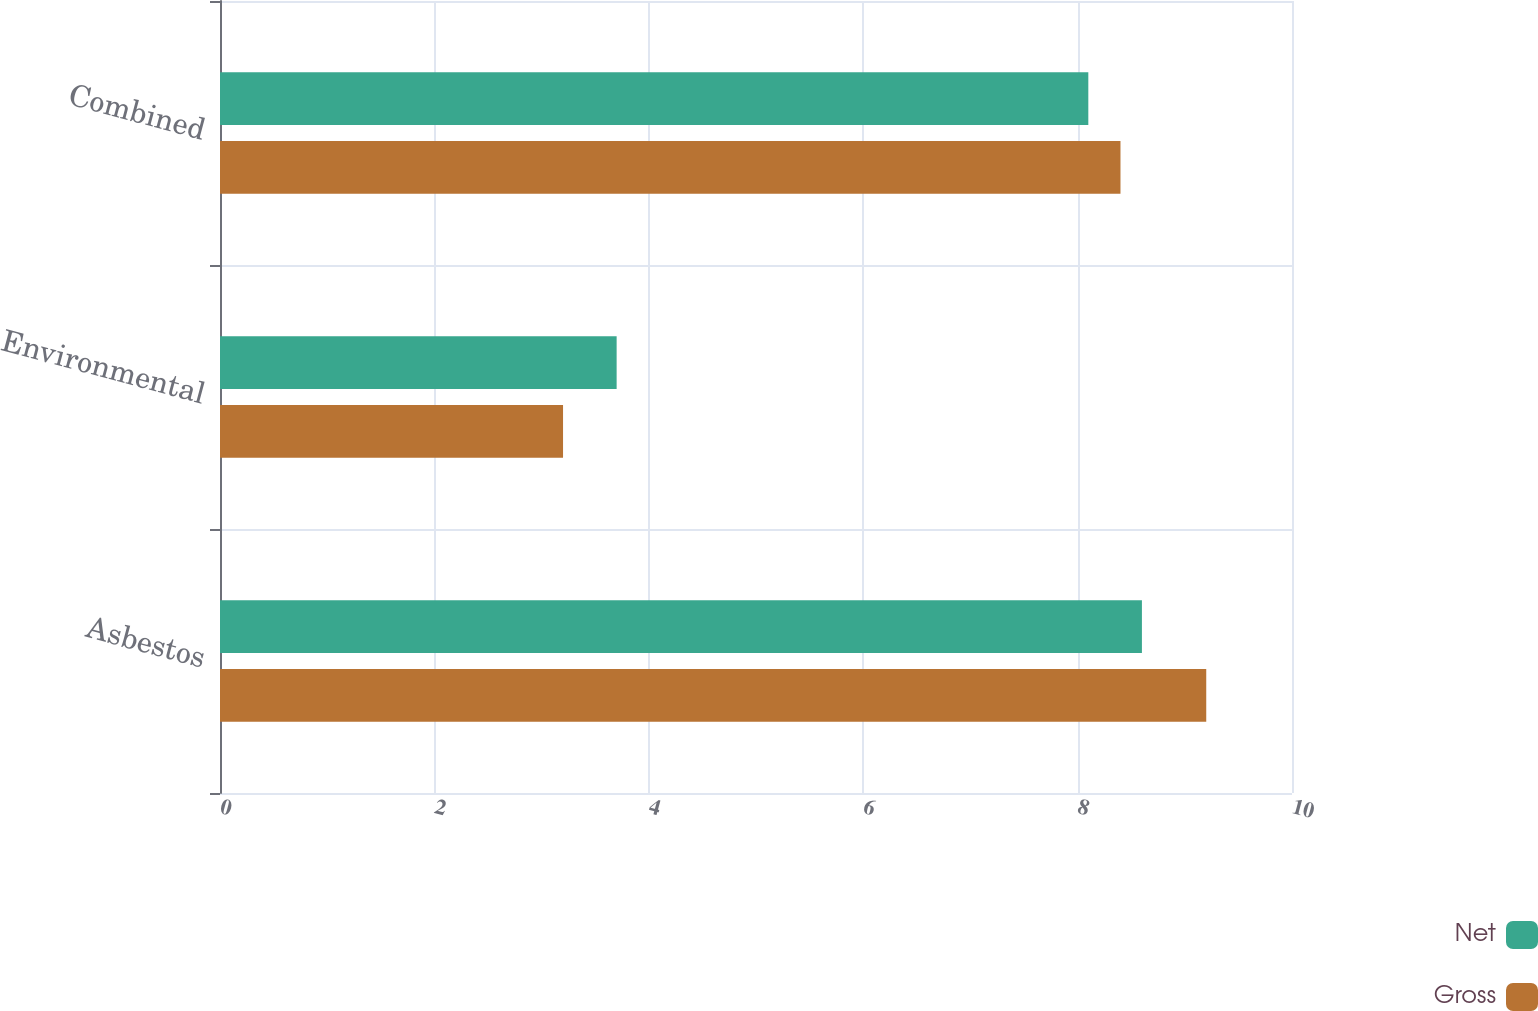Convert chart. <chart><loc_0><loc_0><loc_500><loc_500><stacked_bar_chart><ecel><fcel>Asbestos<fcel>Environmental<fcel>Combined<nl><fcel>Net<fcel>8.6<fcel>3.7<fcel>8.1<nl><fcel>Gross<fcel>9.2<fcel>3.2<fcel>8.4<nl></chart> 